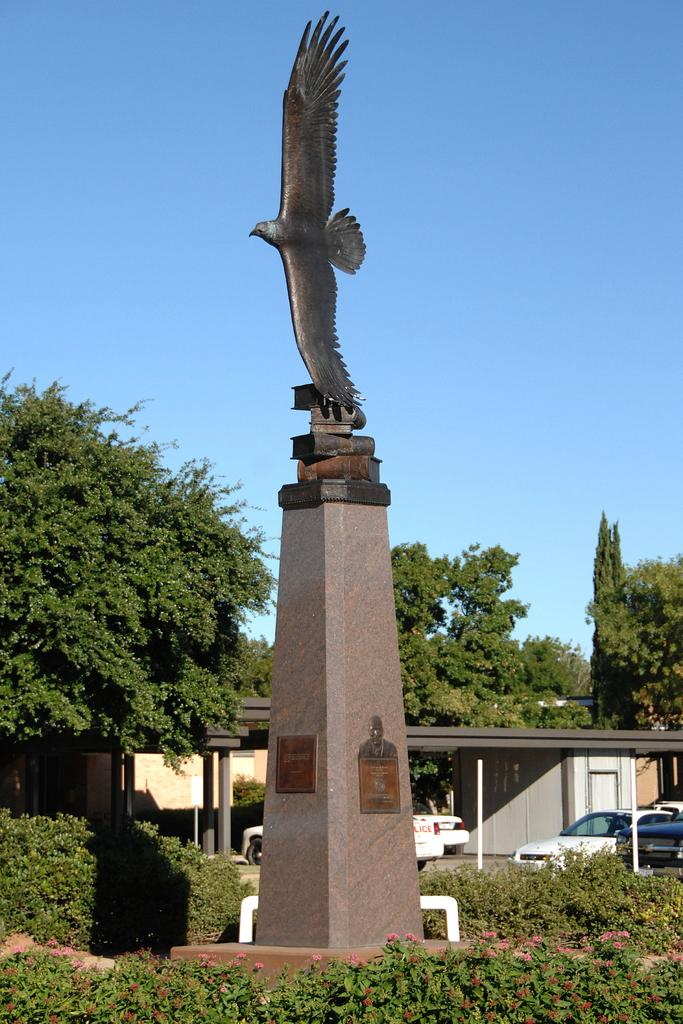What type of plants can be seen in the image? There are plants with flowers in the image. What type of structure is present in the image? There is a shed in the image. What else can be seen in the image besides plants and the shed? There are vehicles, trees, and a statue of a bird on a pillar in the image. What is visible in the background of the image? The sky is visible in the background of the image. Where is the hole in the image? There is no hole present in the image. What type of performance might be happening on the stage in the image? There is no stage present in the image. 